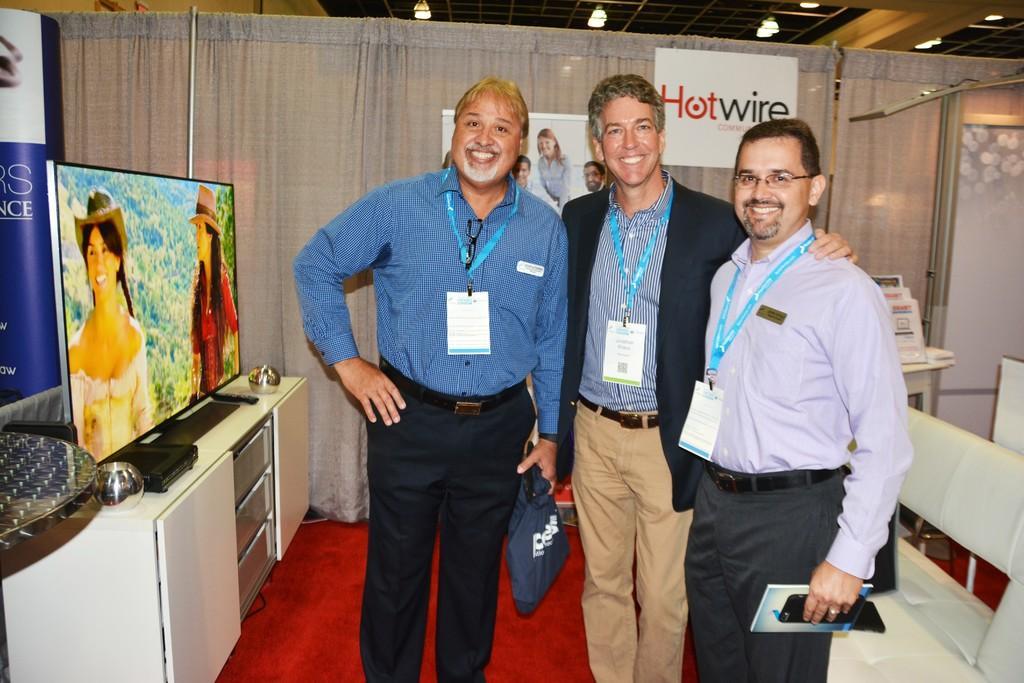Could you give a brief overview of what you see in this image? There are three men standing and smiling and wire tags,this man holding book and mobile and this man holding a bag. Behind this man we can see sofa. We can see television,remote and objects on the furniture and we can see table. in the background we can see banner and board on curtains and objects on the table. 